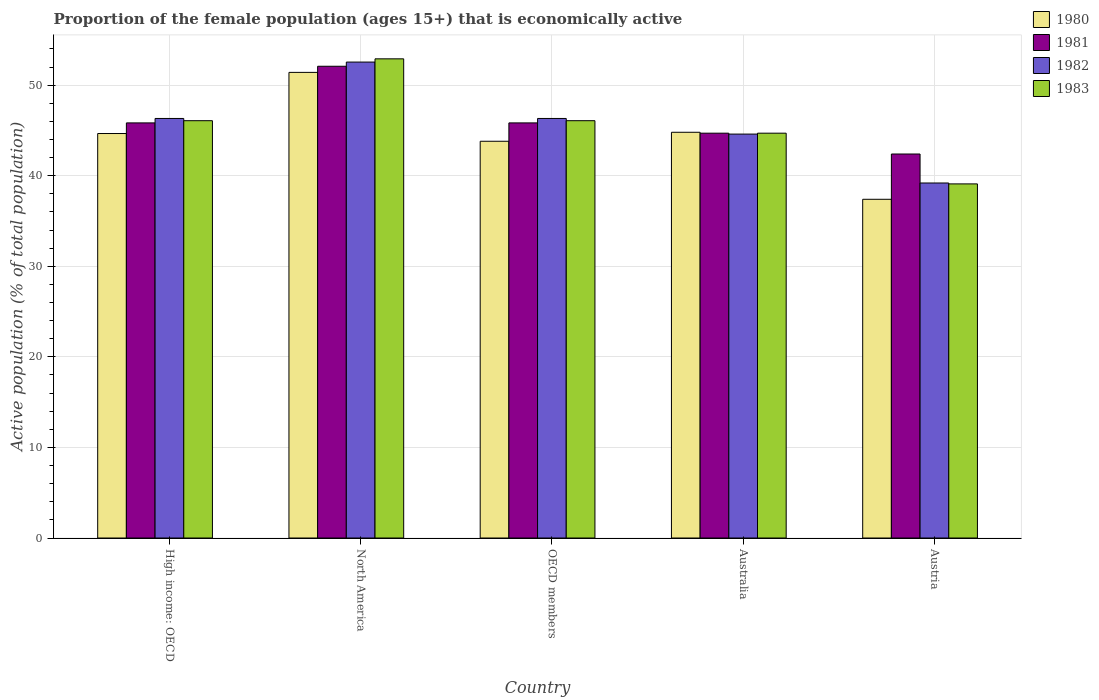How many groups of bars are there?
Ensure brevity in your answer.  5. Are the number of bars on each tick of the X-axis equal?
Keep it short and to the point. Yes. How many bars are there on the 3rd tick from the right?
Give a very brief answer. 4. In how many cases, is the number of bars for a given country not equal to the number of legend labels?
Provide a succinct answer. 0. What is the proportion of the female population that is economically active in 1981 in North America?
Your response must be concise. 52.09. Across all countries, what is the maximum proportion of the female population that is economically active in 1980?
Ensure brevity in your answer.  51.41. Across all countries, what is the minimum proportion of the female population that is economically active in 1983?
Give a very brief answer. 39.1. In which country was the proportion of the female population that is economically active in 1982 maximum?
Make the answer very short. North America. In which country was the proportion of the female population that is economically active in 1980 minimum?
Offer a very short reply. Austria. What is the total proportion of the female population that is economically active in 1983 in the graph?
Ensure brevity in your answer.  228.87. What is the difference between the proportion of the female population that is economically active in 1980 in Austria and that in OECD members?
Provide a succinct answer. -6.41. What is the difference between the proportion of the female population that is economically active in 1980 in Austria and the proportion of the female population that is economically active in 1983 in Australia?
Provide a succinct answer. -7.3. What is the average proportion of the female population that is economically active in 1982 per country?
Your answer should be very brief. 45.8. What is the difference between the proportion of the female population that is economically active of/in 1981 and proportion of the female population that is economically active of/in 1982 in North America?
Make the answer very short. -0.46. What is the ratio of the proportion of the female population that is economically active in 1980 in High income: OECD to that in OECD members?
Provide a succinct answer. 1.02. Is the proportion of the female population that is economically active in 1982 in North America less than that in OECD members?
Provide a short and direct response. No. What is the difference between the highest and the second highest proportion of the female population that is economically active in 1983?
Give a very brief answer. 6.83. What is the difference between the highest and the lowest proportion of the female population that is economically active in 1980?
Offer a terse response. 14.01. In how many countries, is the proportion of the female population that is economically active in 1980 greater than the average proportion of the female population that is economically active in 1980 taken over all countries?
Your answer should be very brief. 3. Is the sum of the proportion of the female population that is economically active in 1983 in Australia and OECD members greater than the maximum proportion of the female population that is economically active in 1982 across all countries?
Provide a succinct answer. Yes. Is it the case that in every country, the sum of the proportion of the female population that is economically active in 1982 and proportion of the female population that is economically active in 1981 is greater than the sum of proportion of the female population that is economically active in 1980 and proportion of the female population that is economically active in 1983?
Your answer should be compact. No. What does the 4th bar from the left in Austria represents?
Your response must be concise. 1983. Are the values on the major ticks of Y-axis written in scientific E-notation?
Your answer should be very brief. No. How many legend labels are there?
Offer a very short reply. 4. What is the title of the graph?
Your response must be concise. Proportion of the female population (ages 15+) that is economically active. Does "1990" appear as one of the legend labels in the graph?
Make the answer very short. No. What is the label or title of the X-axis?
Provide a succinct answer. Country. What is the label or title of the Y-axis?
Provide a succinct answer. Active population (% of total population). What is the Active population (% of total population) in 1980 in High income: OECD?
Ensure brevity in your answer.  44.66. What is the Active population (% of total population) in 1981 in High income: OECD?
Provide a succinct answer. 45.84. What is the Active population (% of total population) in 1982 in High income: OECD?
Provide a short and direct response. 46.32. What is the Active population (% of total population) in 1983 in High income: OECD?
Keep it short and to the point. 46.08. What is the Active population (% of total population) in 1980 in North America?
Offer a very short reply. 51.41. What is the Active population (% of total population) of 1981 in North America?
Provide a short and direct response. 52.09. What is the Active population (% of total population) of 1982 in North America?
Your answer should be very brief. 52.55. What is the Active population (% of total population) of 1983 in North America?
Provide a succinct answer. 52.91. What is the Active population (% of total population) in 1980 in OECD members?
Make the answer very short. 43.81. What is the Active population (% of total population) in 1981 in OECD members?
Offer a very short reply. 45.84. What is the Active population (% of total population) of 1982 in OECD members?
Your answer should be compact. 46.32. What is the Active population (% of total population) in 1983 in OECD members?
Provide a succinct answer. 46.08. What is the Active population (% of total population) in 1980 in Australia?
Your answer should be compact. 44.8. What is the Active population (% of total population) in 1981 in Australia?
Offer a very short reply. 44.7. What is the Active population (% of total population) of 1982 in Australia?
Make the answer very short. 44.6. What is the Active population (% of total population) in 1983 in Australia?
Offer a very short reply. 44.7. What is the Active population (% of total population) in 1980 in Austria?
Ensure brevity in your answer.  37.4. What is the Active population (% of total population) in 1981 in Austria?
Provide a short and direct response. 42.4. What is the Active population (% of total population) in 1982 in Austria?
Offer a terse response. 39.2. What is the Active population (% of total population) in 1983 in Austria?
Give a very brief answer. 39.1. Across all countries, what is the maximum Active population (% of total population) of 1980?
Ensure brevity in your answer.  51.41. Across all countries, what is the maximum Active population (% of total population) of 1981?
Keep it short and to the point. 52.09. Across all countries, what is the maximum Active population (% of total population) in 1982?
Your answer should be very brief. 52.55. Across all countries, what is the maximum Active population (% of total population) in 1983?
Keep it short and to the point. 52.91. Across all countries, what is the minimum Active population (% of total population) in 1980?
Your answer should be compact. 37.4. Across all countries, what is the minimum Active population (% of total population) of 1981?
Provide a short and direct response. 42.4. Across all countries, what is the minimum Active population (% of total population) in 1982?
Ensure brevity in your answer.  39.2. Across all countries, what is the minimum Active population (% of total population) of 1983?
Provide a short and direct response. 39.1. What is the total Active population (% of total population) in 1980 in the graph?
Your answer should be compact. 222.09. What is the total Active population (% of total population) of 1981 in the graph?
Your response must be concise. 230.86. What is the total Active population (% of total population) in 1982 in the graph?
Offer a terse response. 229. What is the total Active population (% of total population) in 1983 in the graph?
Provide a short and direct response. 228.87. What is the difference between the Active population (% of total population) in 1980 in High income: OECD and that in North America?
Offer a terse response. -6.75. What is the difference between the Active population (% of total population) of 1981 in High income: OECD and that in North America?
Provide a succinct answer. -6.25. What is the difference between the Active population (% of total population) of 1982 in High income: OECD and that in North America?
Offer a very short reply. -6.23. What is the difference between the Active population (% of total population) in 1983 in High income: OECD and that in North America?
Offer a terse response. -6.83. What is the difference between the Active population (% of total population) in 1980 in High income: OECD and that in OECD members?
Offer a very short reply. 0.85. What is the difference between the Active population (% of total population) in 1982 in High income: OECD and that in OECD members?
Provide a succinct answer. 0. What is the difference between the Active population (% of total population) in 1983 in High income: OECD and that in OECD members?
Provide a succinct answer. 0. What is the difference between the Active population (% of total population) in 1980 in High income: OECD and that in Australia?
Offer a very short reply. -0.14. What is the difference between the Active population (% of total population) of 1981 in High income: OECD and that in Australia?
Offer a very short reply. 1.14. What is the difference between the Active population (% of total population) of 1982 in High income: OECD and that in Australia?
Your response must be concise. 1.72. What is the difference between the Active population (% of total population) of 1983 in High income: OECD and that in Australia?
Your response must be concise. 1.38. What is the difference between the Active population (% of total population) in 1980 in High income: OECD and that in Austria?
Ensure brevity in your answer.  7.26. What is the difference between the Active population (% of total population) in 1981 in High income: OECD and that in Austria?
Offer a very short reply. 3.44. What is the difference between the Active population (% of total population) in 1982 in High income: OECD and that in Austria?
Give a very brief answer. 7.12. What is the difference between the Active population (% of total population) in 1983 in High income: OECD and that in Austria?
Your response must be concise. 6.98. What is the difference between the Active population (% of total population) of 1980 in North America and that in OECD members?
Provide a short and direct response. 7.61. What is the difference between the Active population (% of total population) in 1981 in North America and that in OECD members?
Make the answer very short. 6.25. What is the difference between the Active population (% of total population) of 1982 in North America and that in OECD members?
Your answer should be compact. 6.23. What is the difference between the Active population (% of total population) in 1983 in North America and that in OECD members?
Offer a very short reply. 6.83. What is the difference between the Active population (% of total population) in 1980 in North America and that in Australia?
Give a very brief answer. 6.61. What is the difference between the Active population (% of total population) in 1981 in North America and that in Australia?
Make the answer very short. 7.39. What is the difference between the Active population (% of total population) of 1982 in North America and that in Australia?
Your answer should be compact. 7.95. What is the difference between the Active population (% of total population) in 1983 in North America and that in Australia?
Your answer should be very brief. 8.21. What is the difference between the Active population (% of total population) in 1980 in North America and that in Austria?
Your response must be concise. 14.01. What is the difference between the Active population (% of total population) of 1981 in North America and that in Austria?
Offer a terse response. 9.69. What is the difference between the Active population (% of total population) of 1982 in North America and that in Austria?
Make the answer very short. 13.35. What is the difference between the Active population (% of total population) in 1983 in North America and that in Austria?
Ensure brevity in your answer.  13.81. What is the difference between the Active population (% of total population) in 1980 in OECD members and that in Australia?
Provide a succinct answer. -0.99. What is the difference between the Active population (% of total population) of 1981 in OECD members and that in Australia?
Make the answer very short. 1.14. What is the difference between the Active population (% of total population) of 1982 in OECD members and that in Australia?
Provide a succinct answer. 1.72. What is the difference between the Active population (% of total population) of 1983 in OECD members and that in Australia?
Make the answer very short. 1.38. What is the difference between the Active population (% of total population) in 1980 in OECD members and that in Austria?
Offer a very short reply. 6.41. What is the difference between the Active population (% of total population) of 1981 in OECD members and that in Austria?
Provide a short and direct response. 3.44. What is the difference between the Active population (% of total population) of 1982 in OECD members and that in Austria?
Your response must be concise. 7.12. What is the difference between the Active population (% of total population) of 1983 in OECD members and that in Austria?
Provide a short and direct response. 6.98. What is the difference between the Active population (% of total population) of 1980 in Australia and that in Austria?
Give a very brief answer. 7.4. What is the difference between the Active population (% of total population) of 1983 in Australia and that in Austria?
Make the answer very short. 5.6. What is the difference between the Active population (% of total population) of 1980 in High income: OECD and the Active population (% of total population) of 1981 in North America?
Your answer should be very brief. -7.43. What is the difference between the Active population (% of total population) of 1980 in High income: OECD and the Active population (% of total population) of 1982 in North America?
Your answer should be compact. -7.89. What is the difference between the Active population (% of total population) in 1980 in High income: OECD and the Active population (% of total population) in 1983 in North America?
Give a very brief answer. -8.25. What is the difference between the Active population (% of total population) in 1981 in High income: OECD and the Active population (% of total population) in 1982 in North America?
Your response must be concise. -6.72. What is the difference between the Active population (% of total population) of 1981 in High income: OECD and the Active population (% of total population) of 1983 in North America?
Offer a very short reply. -7.07. What is the difference between the Active population (% of total population) in 1982 in High income: OECD and the Active population (% of total population) in 1983 in North America?
Make the answer very short. -6.58. What is the difference between the Active population (% of total population) in 1980 in High income: OECD and the Active population (% of total population) in 1981 in OECD members?
Provide a succinct answer. -1.17. What is the difference between the Active population (% of total population) of 1980 in High income: OECD and the Active population (% of total population) of 1982 in OECD members?
Provide a succinct answer. -1.66. What is the difference between the Active population (% of total population) in 1980 in High income: OECD and the Active population (% of total population) in 1983 in OECD members?
Your response must be concise. -1.42. What is the difference between the Active population (% of total population) of 1981 in High income: OECD and the Active population (% of total population) of 1982 in OECD members?
Keep it short and to the point. -0.49. What is the difference between the Active population (% of total population) of 1981 in High income: OECD and the Active population (% of total population) of 1983 in OECD members?
Provide a succinct answer. -0.24. What is the difference between the Active population (% of total population) in 1982 in High income: OECD and the Active population (% of total population) in 1983 in OECD members?
Offer a very short reply. 0.25. What is the difference between the Active population (% of total population) of 1980 in High income: OECD and the Active population (% of total population) of 1981 in Australia?
Offer a terse response. -0.04. What is the difference between the Active population (% of total population) in 1980 in High income: OECD and the Active population (% of total population) in 1982 in Australia?
Provide a succinct answer. 0.06. What is the difference between the Active population (% of total population) in 1980 in High income: OECD and the Active population (% of total population) in 1983 in Australia?
Your response must be concise. -0.04. What is the difference between the Active population (% of total population) in 1981 in High income: OECD and the Active population (% of total population) in 1982 in Australia?
Keep it short and to the point. 1.24. What is the difference between the Active population (% of total population) in 1981 in High income: OECD and the Active population (% of total population) in 1983 in Australia?
Provide a succinct answer. 1.14. What is the difference between the Active population (% of total population) of 1982 in High income: OECD and the Active population (% of total population) of 1983 in Australia?
Keep it short and to the point. 1.62. What is the difference between the Active population (% of total population) of 1980 in High income: OECD and the Active population (% of total population) of 1981 in Austria?
Offer a very short reply. 2.26. What is the difference between the Active population (% of total population) of 1980 in High income: OECD and the Active population (% of total population) of 1982 in Austria?
Your answer should be compact. 5.46. What is the difference between the Active population (% of total population) in 1980 in High income: OECD and the Active population (% of total population) in 1983 in Austria?
Your answer should be compact. 5.56. What is the difference between the Active population (% of total population) of 1981 in High income: OECD and the Active population (% of total population) of 1982 in Austria?
Offer a very short reply. 6.64. What is the difference between the Active population (% of total population) in 1981 in High income: OECD and the Active population (% of total population) in 1983 in Austria?
Your response must be concise. 6.74. What is the difference between the Active population (% of total population) in 1982 in High income: OECD and the Active population (% of total population) in 1983 in Austria?
Give a very brief answer. 7.22. What is the difference between the Active population (% of total population) in 1980 in North America and the Active population (% of total population) in 1981 in OECD members?
Ensure brevity in your answer.  5.58. What is the difference between the Active population (% of total population) of 1980 in North America and the Active population (% of total population) of 1982 in OECD members?
Offer a very short reply. 5.09. What is the difference between the Active population (% of total population) in 1980 in North America and the Active population (% of total population) in 1983 in OECD members?
Offer a very short reply. 5.34. What is the difference between the Active population (% of total population) in 1981 in North America and the Active population (% of total population) in 1982 in OECD members?
Your answer should be very brief. 5.77. What is the difference between the Active population (% of total population) of 1981 in North America and the Active population (% of total population) of 1983 in OECD members?
Make the answer very short. 6.01. What is the difference between the Active population (% of total population) of 1982 in North America and the Active population (% of total population) of 1983 in OECD members?
Make the answer very short. 6.47. What is the difference between the Active population (% of total population) in 1980 in North America and the Active population (% of total population) in 1981 in Australia?
Offer a terse response. 6.71. What is the difference between the Active population (% of total population) in 1980 in North America and the Active population (% of total population) in 1982 in Australia?
Make the answer very short. 6.81. What is the difference between the Active population (% of total population) in 1980 in North America and the Active population (% of total population) in 1983 in Australia?
Ensure brevity in your answer.  6.71. What is the difference between the Active population (% of total population) of 1981 in North America and the Active population (% of total population) of 1982 in Australia?
Offer a terse response. 7.49. What is the difference between the Active population (% of total population) of 1981 in North America and the Active population (% of total population) of 1983 in Australia?
Your answer should be compact. 7.39. What is the difference between the Active population (% of total population) of 1982 in North America and the Active population (% of total population) of 1983 in Australia?
Offer a terse response. 7.85. What is the difference between the Active population (% of total population) in 1980 in North America and the Active population (% of total population) in 1981 in Austria?
Ensure brevity in your answer.  9.01. What is the difference between the Active population (% of total population) of 1980 in North America and the Active population (% of total population) of 1982 in Austria?
Your answer should be compact. 12.21. What is the difference between the Active population (% of total population) of 1980 in North America and the Active population (% of total population) of 1983 in Austria?
Your answer should be very brief. 12.31. What is the difference between the Active population (% of total population) of 1981 in North America and the Active population (% of total population) of 1982 in Austria?
Your answer should be compact. 12.89. What is the difference between the Active population (% of total population) in 1981 in North America and the Active population (% of total population) in 1983 in Austria?
Your answer should be very brief. 12.99. What is the difference between the Active population (% of total population) in 1982 in North America and the Active population (% of total population) in 1983 in Austria?
Make the answer very short. 13.45. What is the difference between the Active population (% of total population) of 1980 in OECD members and the Active population (% of total population) of 1981 in Australia?
Your answer should be compact. -0.89. What is the difference between the Active population (% of total population) in 1980 in OECD members and the Active population (% of total population) in 1982 in Australia?
Your response must be concise. -0.79. What is the difference between the Active population (% of total population) in 1980 in OECD members and the Active population (% of total population) in 1983 in Australia?
Make the answer very short. -0.89. What is the difference between the Active population (% of total population) of 1981 in OECD members and the Active population (% of total population) of 1982 in Australia?
Ensure brevity in your answer.  1.24. What is the difference between the Active population (% of total population) in 1981 in OECD members and the Active population (% of total population) in 1983 in Australia?
Offer a terse response. 1.14. What is the difference between the Active population (% of total population) of 1982 in OECD members and the Active population (% of total population) of 1983 in Australia?
Give a very brief answer. 1.62. What is the difference between the Active population (% of total population) in 1980 in OECD members and the Active population (% of total population) in 1981 in Austria?
Give a very brief answer. 1.41. What is the difference between the Active population (% of total population) of 1980 in OECD members and the Active population (% of total population) of 1982 in Austria?
Ensure brevity in your answer.  4.61. What is the difference between the Active population (% of total population) in 1980 in OECD members and the Active population (% of total population) in 1983 in Austria?
Your response must be concise. 4.71. What is the difference between the Active population (% of total population) in 1981 in OECD members and the Active population (% of total population) in 1982 in Austria?
Provide a short and direct response. 6.64. What is the difference between the Active population (% of total population) of 1981 in OECD members and the Active population (% of total population) of 1983 in Austria?
Provide a short and direct response. 6.74. What is the difference between the Active population (% of total population) in 1982 in OECD members and the Active population (% of total population) in 1983 in Austria?
Offer a very short reply. 7.22. What is the difference between the Active population (% of total population) of 1980 in Australia and the Active population (% of total population) of 1982 in Austria?
Your answer should be very brief. 5.6. What is the difference between the Active population (% of total population) in 1980 in Australia and the Active population (% of total population) in 1983 in Austria?
Your answer should be compact. 5.7. What is the difference between the Active population (% of total population) in 1981 in Australia and the Active population (% of total population) in 1982 in Austria?
Ensure brevity in your answer.  5.5. What is the difference between the Active population (% of total population) of 1982 in Australia and the Active population (% of total population) of 1983 in Austria?
Your answer should be very brief. 5.5. What is the average Active population (% of total population) in 1980 per country?
Offer a very short reply. 44.42. What is the average Active population (% of total population) of 1981 per country?
Make the answer very short. 46.17. What is the average Active population (% of total population) in 1982 per country?
Make the answer very short. 45.8. What is the average Active population (% of total population) in 1983 per country?
Provide a succinct answer. 45.77. What is the difference between the Active population (% of total population) in 1980 and Active population (% of total population) in 1981 in High income: OECD?
Keep it short and to the point. -1.17. What is the difference between the Active population (% of total population) of 1980 and Active population (% of total population) of 1982 in High income: OECD?
Your response must be concise. -1.66. What is the difference between the Active population (% of total population) in 1980 and Active population (% of total population) in 1983 in High income: OECD?
Keep it short and to the point. -1.42. What is the difference between the Active population (% of total population) of 1981 and Active population (% of total population) of 1982 in High income: OECD?
Offer a terse response. -0.49. What is the difference between the Active population (% of total population) of 1981 and Active population (% of total population) of 1983 in High income: OECD?
Offer a terse response. -0.24. What is the difference between the Active population (% of total population) of 1982 and Active population (% of total population) of 1983 in High income: OECD?
Your answer should be compact. 0.25. What is the difference between the Active population (% of total population) of 1980 and Active population (% of total population) of 1981 in North America?
Make the answer very short. -0.68. What is the difference between the Active population (% of total population) of 1980 and Active population (% of total population) of 1982 in North America?
Provide a succinct answer. -1.14. What is the difference between the Active population (% of total population) of 1980 and Active population (% of total population) of 1983 in North America?
Your answer should be very brief. -1.5. What is the difference between the Active population (% of total population) of 1981 and Active population (% of total population) of 1982 in North America?
Provide a succinct answer. -0.46. What is the difference between the Active population (% of total population) of 1981 and Active population (% of total population) of 1983 in North America?
Your answer should be very brief. -0.82. What is the difference between the Active population (% of total population) in 1982 and Active population (% of total population) in 1983 in North America?
Provide a succinct answer. -0.36. What is the difference between the Active population (% of total population) in 1980 and Active population (% of total population) in 1981 in OECD members?
Ensure brevity in your answer.  -2.03. What is the difference between the Active population (% of total population) of 1980 and Active population (% of total population) of 1982 in OECD members?
Give a very brief answer. -2.52. What is the difference between the Active population (% of total population) in 1980 and Active population (% of total population) in 1983 in OECD members?
Ensure brevity in your answer.  -2.27. What is the difference between the Active population (% of total population) in 1981 and Active population (% of total population) in 1982 in OECD members?
Your response must be concise. -0.49. What is the difference between the Active population (% of total population) in 1981 and Active population (% of total population) in 1983 in OECD members?
Make the answer very short. -0.24. What is the difference between the Active population (% of total population) of 1982 and Active population (% of total population) of 1983 in OECD members?
Provide a short and direct response. 0.25. What is the difference between the Active population (% of total population) of 1980 and Active population (% of total population) of 1981 in Australia?
Provide a short and direct response. 0.1. What is the difference between the Active population (% of total population) of 1981 and Active population (% of total population) of 1982 in Australia?
Your answer should be compact. 0.1. What is the difference between the Active population (% of total population) in 1981 and Active population (% of total population) in 1983 in Australia?
Give a very brief answer. 0. What is the difference between the Active population (% of total population) of 1982 and Active population (% of total population) of 1983 in Australia?
Provide a short and direct response. -0.1. What is the difference between the Active population (% of total population) in 1981 and Active population (% of total population) in 1982 in Austria?
Offer a very short reply. 3.2. What is the difference between the Active population (% of total population) in 1982 and Active population (% of total population) in 1983 in Austria?
Your response must be concise. 0.1. What is the ratio of the Active population (% of total population) of 1980 in High income: OECD to that in North America?
Provide a succinct answer. 0.87. What is the ratio of the Active population (% of total population) in 1981 in High income: OECD to that in North America?
Offer a terse response. 0.88. What is the ratio of the Active population (% of total population) of 1982 in High income: OECD to that in North America?
Your answer should be compact. 0.88. What is the ratio of the Active population (% of total population) of 1983 in High income: OECD to that in North America?
Make the answer very short. 0.87. What is the ratio of the Active population (% of total population) in 1980 in High income: OECD to that in OECD members?
Offer a terse response. 1.02. What is the ratio of the Active population (% of total population) in 1982 in High income: OECD to that in OECD members?
Keep it short and to the point. 1. What is the ratio of the Active population (% of total population) in 1983 in High income: OECD to that in OECD members?
Provide a succinct answer. 1. What is the ratio of the Active population (% of total population) in 1981 in High income: OECD to that in Australia?
Give a very brief answer. 1.03. What is the ratio of the Active population (% of total population) in 1982 in High income: OECD to that in Australia?
Ensure brevity in your answer.  1.04. What is the ratio of the Active population (% of total population) in 1983 in High income: OECD to that in Australia?
Provide a short and direct response. 1.03. What is the ratio of the Active population (% of total population) in 1980 in High income: OECD to that in Austria?
Give a very brief answer. 1.19. What is the ratio of the Active population (% of total population) of 1981 in High income: OECD to that in Austria?
Offer a terse response. 1.08. What is the ratio of the Active population (% of total population) in 1982 in High income: OECD to that in Austria?
Your response must be concise. 1.18. What is the ratio of the Active population (% of total population) in 1983 in High income: OECD to that in Austria?
Your response must be concise. 1.18. What is the ratio of the Active population (% of total population) of 1980 in North America to that in OECD members?
Your answer should be compact. 1.17. What is the ratio of the Active population (% of total population) in 1981 in North America to that in OECD members?
Your response must be concise. 1.14. What is the ratio of the Active population (% of total population) of 1982 in North America to that in OECD members?
Ensure brevity in your answer.  1.13. What is the ratio of the Active population (% of total population) of 1983 in North America to that in OECD members?
Keep it short and to the point. 1.15. What is the ratio of the Active population (% of total population) of 1980 in North America to that in Australia?
Your response must be concise. 1.15. What is the ratio of the Active population (% of total population) of 1981 in North America to that in Australia?
Provide a succinct answer. 1.17. What is the ratio of the Active population (% of total population) of 1982 in North America to that in Australia?
Offer a very short reply. 1.18. What is the ratio of the Active population (% of total population) in 1983 in North America to that in Australia?
Give a very brief answer. 1.18. What is the ratio of the Active population (% of total population) in 1980 in North America to that in Austria?
Provide a succinct answer. 1.37. What is the ratio of the Active population (% of total population) of 1981 in North America to that in Austria?
Make the answer very short. 1.23. What is the ratio of the Active population (% of total population) in 1982 in North America to that in Austria?
Provide a succinct answer. 1.34. What is the ratio of the Active population (% of total population) of 1983 in North America to that in Austria?
Provide a short and direct response. 1.35. What is the ratio of the Active population (% of total population) in 1980 in OECD members to that in Australia?
Keep it short and to the point. 0.98. What is the ratio of the Active population (% of total population) of 1981 in OECD members to that in Australia?
Your answer should be compact. 1.03. What is the ratio of the Active population (% of total population) in 1982 in OECD members to that in Australia?
Provide a short and direct response. 1.04. What is the ratio of the Active population (% of total population) in 1983 in OECD members to that in Australia?
Ensure brevity in your answer.  1.03. What is the ratio of the Active population (% of total population) in 1980 in OECD members to that in Austria?
Your response must be concise. 1.17. What is the ratio of the Active population (% of total population) of 1981 in OECD members to that in Austria?
Keep it short and to the point. 1.08. What is the ratio of the Active population (% of total population) of 1982 in OECD members to that in Austria?
Make the answer very short. 1.18. What is the ratio of the Active population (% of total population) in 1983 in OECD members to that in Austria?
Ensure brevity in your answer.  1.18. What is the ratio of the Active population (% of total population) in 1980 in Australia to that in Austria?
Make the answer very short. 1.2. What is the ratio of the Active population (% of total population) in 1981 in Australia to that in Austria?
Your answer should be very brief. 1.05. What is the ratio of the Active population (% of total population) in 1982 in Australia to that in Austria?
Offer a very short reply. 1.14. What is the ratio of the Active population (% of total population) in 1983 in Australia to that in Austria?
Your response must be concise. 1.14. What is the difference between the highest and the second highest Active population (% of total population) in 1980?
Your answer should be very brief. 6.61. What is the difference between the highest and the second highest Active population (% of total population) of 1981?
Offer a terse response. 6.25. What is the difference between the highest and the second highest Active population (% of total population) in 1982?
Offer a very short reply. 6.23. What is the difference between the highest and the second highest Active population (% of total population) in 1983?
Give a very brief answer. 6.83. What is the difference between the highest and the lowest Active population (% of total population) in 1980?
Provide a short and direct response. 14.01. What is the difference between the highest and the lowest Active population (% of total population) of 1981?
Offer a very short reply. 9.69. What is the difference between the highest and the lowest Active population (% of total population) of 1982?
Your answer should be very brief. 13.35. What is the difference between the highest and the lowest Active population (% of total population) of 1983?
Your answer should be compact. 13.81. 